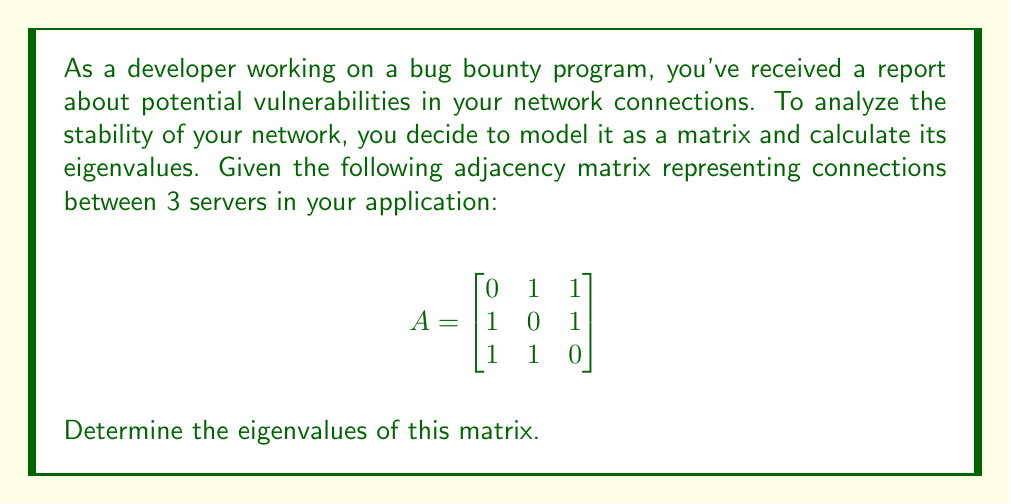Teach me how to tackle this problem. To find the eigenvalues of matrix $A$, we need to solve the characteristic equation:

1) First, we set up the equation: $\det(A - \lambda I) = 0$, where $I$ is the 3x3 identity matrix.

2) Expanding this, we get:
   $$\det\begin{pmatrix}
   -\lambda & 1 & 1 \\
   1 & -\lambda & 1 \\
   1 & 1 & -\lambda
   \end{pmatrix} = 0$$

3) Calculate the determinant:
   $(-\lambda)(-\lambda)(-\lambda) + (1)(1)(1) + (1)(1)(1) - (1)(1)(-\lambda) - (1)(-\lambda)(1) - (-\lambda)(1)(1) = 0$

4) Simplify:
   $-\lambda^3 + 2 - 3\lambda = 0$

5) Rearrange to standard form:
   $\lambda^3 + 3\lambda - 2 = 0$

6) This cubic equation can be factored as:
   $(\lambda + 2)(\lambda^2 - 2\lambda - 1) = 0$

7) Solve each factor:
   $\lambda = -2$ or $\lambda^2 - 2\lambda - 1 = 0$

8) Use the quadratic formula for the second factor:
   $\lambda = \frac{2 \pm \sqrt{4 + 4}}{2} = 1 \pm \sqrt{2}$

Therefore, the eigenvalues are $-2$, $1 + \sqrt{2}$, and $1 - \sqrt{2}$.
Answer: $-2$, $1 + \sqrt{2}$, $1 - \sqrt{2}$ 